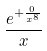Convert formula to latex. <formula><loc_0><loc_0><loc_500><loc_500>\frac { e ^ { + \frac { 0 } { x ^ { 8 } } } } { x }</formula> 